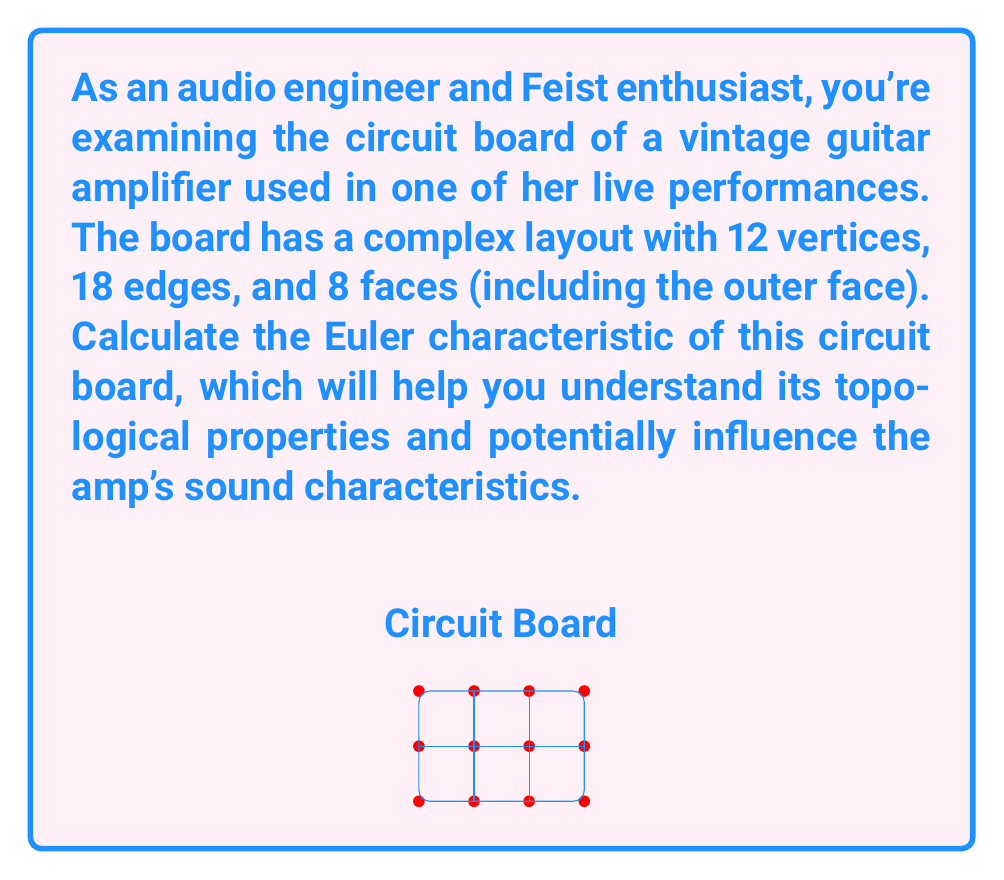Provide a solution to this math problem. To calculate the Euler characteristic of the circuit board, we'll use the Euler formula for planar graphs:

$$\chi = V - E + F$$

Where:
$\chi$ is the Euler characteristic
$V$ is the number of vertices
$E$ is the number of edges
$F$ is the number of faces (including the outer face)

Given:
- Number of vertices (V) = 12
- Number of edges (E) = 18
- Number of faces (F) = 8

Let's substitute these values into the formula:

$$\chi = V - E + F$$
$$\chi = 12 - 18 + 8$$
$$\chi = 2$$

The Euler characteristic of the circuit board is 2, which is consistent with the topological properties of a sphere or a plane. This indicates that the circuit board is essentially a flat surface without any holes, which is typical for most printed circuit boards.

For an audio engineer, this result suggests that the circuit board has a standard planar layout, which is good for signal integrity and ease of manufacturing. The absence of topological holes (which would result in a different Euler characteristic) indicates that there are no complex crossovers or multi-layer designs that might introduce unwanted noise or interference in the audio signal path.
Answer: $\chi = 2$ 